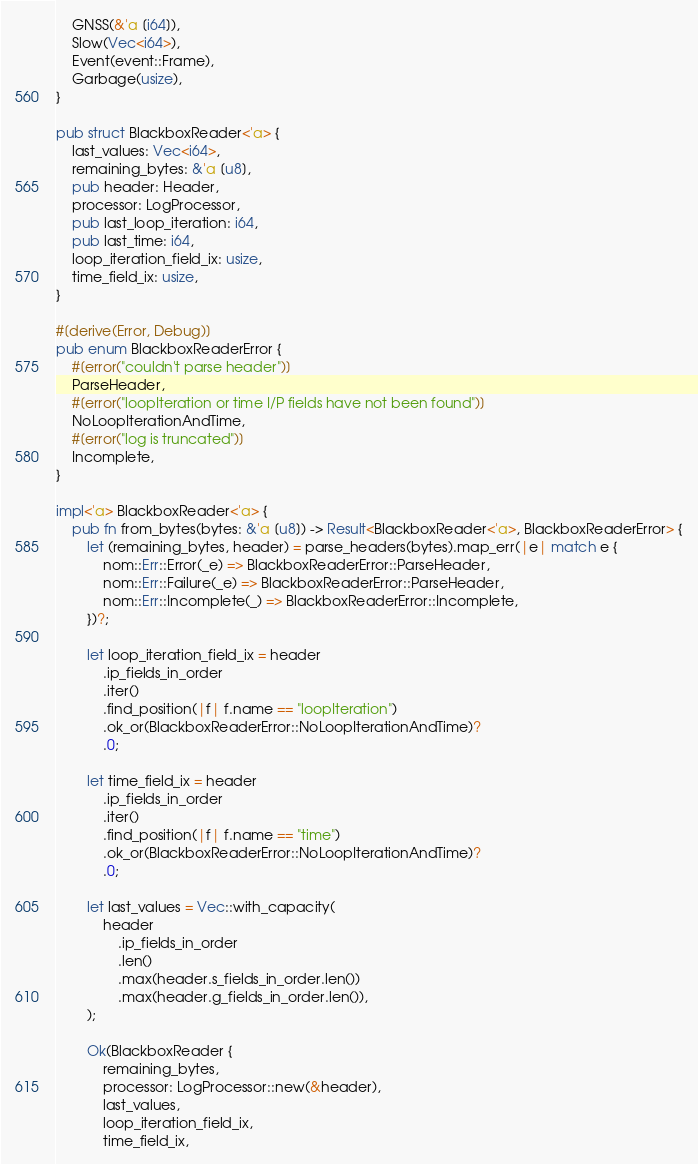<code> <loc_0><loc_0><loc_500><loc_500><_Rust_>    GNSS(&'a [i64]),
    Slow(Vec<i64>),
    Event(event::Frame),
    Garbage(usize),
}

pub struct BlackboxReader<'a> {
    last_values: Vec<i64>,
    remaining_bytes: &'a [u8],
    pub header: Header,
    processor: LogProcessor,
    pub last_loop_iteration: i64,
    pub last_time: i64,
    loop_iteration_field_ix: usize,
    time_field_ix: usize,
}

#[derive(Error, Debug)]
pub enum BlackboxReaderError {
    #[error("couldn't parse header")]
    ParseHeader,
    #[error("loopIteration or time I/P fields have not been found")]
    NoLoopIterationAndTime,
    #[error("log is truncated")]
    Incomplete,
}

impl<'a> BlackboxReader<'a> {
    pub fn from_bytes(bytes: &'a [u8]) -> Result<BlackboxReader<'a>, BlackboxReaderError> {
        let (remaining_bytes, header) = parse_headers(bytes).map_err(|e| match e {
            nom::Err::Error(_e) => BlackboxReaderError::ParseHeader,
            nom::Err::Failure(_e) => BlackboxReaderError::ParseHeader,
            nom::Err::Incomplete(_) => BlackboxReaderError::Incomplete,
        })?;

        let loop_iteration_field_ix = header
            .ip_fields_in_order
            .iter()
            .find_position(|f| f.name == "loopIteration")
            .ok_or(BlackboxReaderError::NoLoopIterationAndTime)?
            .0;

        let time_field_ix = header
            .ip_fields_in_order
            .iter()
            .find_position(|f| f.name == "time")
            .ok_or(BlackboxReaderError::NoLoopIterationAndTime)?
            .0;

        let last_values = Vec::with_capacity(
            header
                .ip_fields_in_order
                .len()
                .max(header.s_fields_in_order.len())
                .max(header.g_fields_in_order.len()),
        );

        Ok(BlackboxReader {
            remaining_bytes,
            processor: LogProcessor::new(&header),
            last_values,
            loop_iteration_field_ix,
            time_field_ix,</code> 